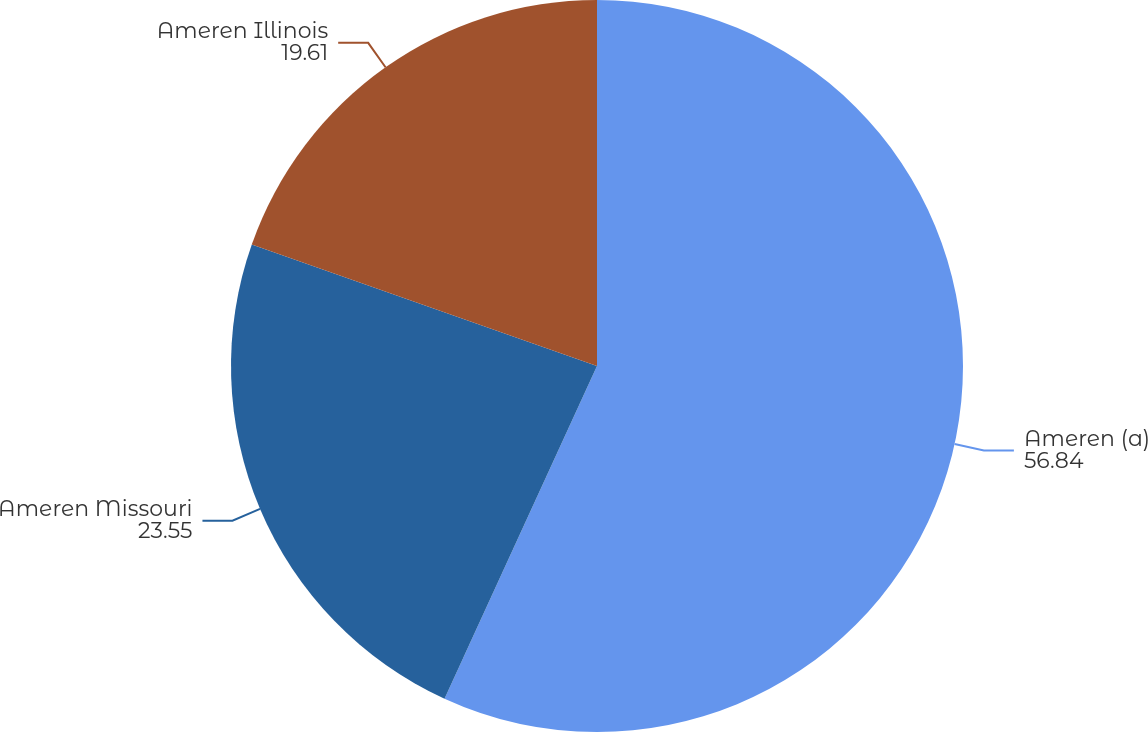Convert chart. <chart><loc_0><loc_0><loc_500><loc_500><pie_chart><fcel>Ameren (a)<fcel>Ameren Missouri<fcel>Ameren Illinois<nl><fcel>56.84%<fcel>23.55%<fcel>19.61%<nl></chart> 